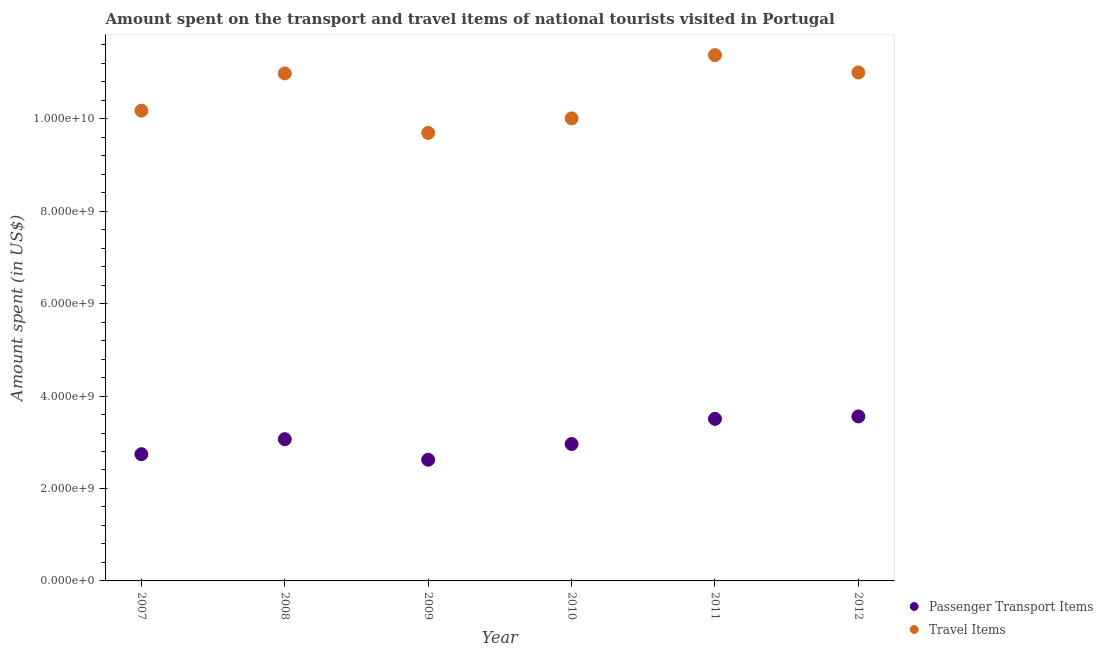How many different coloured dotlines are there?
Your response must be concise. 2. Is the number of dotlines equal to the number of legend labels?
Provide a succinct answer. Yes. What is the amount spent on passenger transport items in 2012?
Give a very brief answer. 3.56e+09. Across all years, what is the maximum amount spent in travel items?
Your answer should be compact. 1.14e+1. Across all years, what is the minimum amount spent on passenger transport items?
Provide a short and direct response. 2.62e+09. In which year was the amount spent on passenger transport items maximum?
Provide a short and direct response. 2012. In which year was the amount spent in travel items minimum?
Provide a short and direct response. 2009. What is the total amount spent on passenger transport items in the graph?
Your answer should be compact. 1.85e+1. What is the difference between the amount spent on passenger transport items in 2007 and that in 2012?
Keep it short and to the point. -8.17e+08. What is the difference between the amount spent in travel items in 2010 and the amount spent on passenger transport items in 2008?
Make the answer very short. 6.94e+09. What is the average amount spent in travel items per year?
Make the answer very short. 1.05e+1. In the year 2008, what is the difference between the amount spent in travel items and amount spent on passenger transport items?
Keep it short and to the point. 7.91e+09. In how many years, is the amount spent in travel items greater than 3600000000 US$?
Your answer should be very brief. 6. What is the ratio of the amount spent in travel items in 2008 to that in 2009?
Make the answer very short. 1.13. Is the amount spent in travel items in 2010 less than that in 2012?
Provide a succinct answer. Yes. Is the difference between the amount spent in travel items in 2007 and 2011 greater than the difference between the amount spent on passenger transport items in 2007 and 2011?
Your answer should be very brief. No. What is the difference between the highest and the second highest amount spent on passenger transport items?
Ensure brevity in your answer.  5.30e+07. What is the difference between the highest and the lowest amount spent in travel items?
Give a very brief answer. 1.68e+09. In how many years, is the amount spent on passenger transport items greater than the average amount spent on passenger transport items taken over all years?
Offer a very short reply. 2. Does the amount spent in travel items monotonically increase over the years?
Provide a short and direct response. No. Is the amount spent on passenger transport items strictly less than the amount spent in travel items over the years?
Offer a very short reply. Yes. How many dotlines are there?
Ensure brevity in your answer.  2. How many years are there in the graph?
Keep it short and to the point. 6. What is the difference between two consecutive major ticks on the Y-axis?
Make the answer very short. 2.00e+09. Are the values on the major ticks of Y-axis written in scientific E-notation?
Offer a very short reply. Yes. Does the graph contain any zero values?
Offer a terse response. No. Does the graph contain grids?
Give a very brief answer. No. Where does the legend appear in the graph?
Provide a succinct answer. Bottom right. How many legend labels are there?
Provide a short and direct response. 2. How are the legend labels stacked?
Offer a terse response. Vertical. What is the title of the graph?
Keep it short and to the point. Amount spent on the transport and travel items of national tourists visited in Portugal. Does "Agricultural land" appear as one of the legend labels in the graph?
Your answer should be compact. No. What is the label or title of the X-axis?
Keep it short and to the point. Year. What is the label or title of the Y-axis?
Offer a very short reply. Amount spent (in US$). What is the Amount spent (in US$) in Passenger Transport Items in 2007?
Your answer should be very brief. 2.74e+09. What is the Amount spent (in US$) in Travel Items in 2007?
Provide a succinct answer. 1.02e+1. What is the Amount spent (in US$) of Passenger Transport Items in 2008?
Make the answer very short. 3.07e+09. What is the Amount spent (in US$) of Travel Items in 2008?
Your answer should be very brief. 1.10e+1. What is the Amount spent (in US$) in Passenger Transport Items in 2009?
Offer a terse response. 2.62e+09. What is the Amount spent (in US$) in Travel Items in 2009?
Your response must be concise. 9.69e+09. What is the Amount spent (in US$) in Passenger Transport Items in 2010?
Ensure brevity in your answer.  2.96e+09. What is the Amount spent (in US$) in Travel Items in 2010?
Make the answer very short. 1.00e+1. What is the Amount spent (in US$) of Passenger Transport Items in 2011?
Make the answer very short. 3.51e+09. What is the Amount spent (in US$) in Travel Items in 2011?
Your answer should be compact. 1.14e+1. What is the Amount spent (in US$) in Passenger Transport Items in 2012?
Make the answer very short. 3.56e+09. What is the Amount spent (in US$) of Travel Items in 2012?
Provide a short and direct response. 1.10e+1. Across all years, what is the maximum Amount spent (in US$) of Passenger Transport Items?
Provide a short and direct response. 3.56e+09. Across all years, what is the maximum Amount spent (in US$) of Travel Items?
Provide a short and direct response. 1.14e+1. Across all years, what is the minimum Amount spent (in US$) in Passenger Transport Items?
Provide a succinct answer. 2.62e+09. Across all years, what is the minimum Amount spent (in US$) of Travel Items?
Keep it short and to the point. 9.69e+09. What is the total Amount spent (in US$) of Passenger Transport Items in the graph?
Offer a very short reply. 1.85e+1. What is the total Amount spent (in US$) of Travel Items in the graph?
Offer a very short reply. 6.32e+1. What is the difference between the Amount spent (in US$) of Passenger Transport Items in 2007 and that in 2008?
Provide a succinct answer. -3.25e+08. What is the difference between the Amount spent (in US$) in Travel Items in 2007 and that in 2008?
Offer a very short reply. -8.05e+08. What is the difference between the Amount spent (in US$) of Passenger Transport Items in 2007 and that in 2009?
Your answer should be compact. 1.20e+08. What is the difference between the Amount spent (in US$) in Travel Items in 2007 and that in 2009?
Ensure brevity in your answer.  4.82e+08. What is the difference between the Amount spent (in US$) of Passenger Transport Items in 2007 and that in 2010?
Your answer should be very brief. -2.20e+08. What is the difference between the Amount spent (in US$) of Travel Items in 2007 and that in 2010?
Provide a short and direct response. 1.68e+08. What is the difference between the Amount spent (in US$) in Passenger Transport Items in 2007 and that in 2011?
Provide a short and direct response. -7.64e+08. What is the difference between the Amount spent (in US$) in Travel Items in 2007 and that in 2011?
Your answer should be very brief. -1.20e+09. What is the difference between the Amount spent (in US$) of Passenger Transport Items in 2007 and that in 2012?
Offer a very short reply. -8.17e+08. What is the difference between the Amount spent (in US$) in Travel Items in 2007 and that in 2012?
Your response must be concise. -8.25e+08. What is the difference between the Amount spent (in US$) in Passenger Transport Items in 2008 and that in 2009?
Your response must be concise. 4.45e+08. What is the difference between the Amount spent (in US$) in Travel Items in 2008 and that in 2009?
Your answer should be compact. 1.29e+09. What is the difference between the Amount spent (in US$) in Passenger Transport Items in 2008 and that in 2010?
Provide a succinct answer. 1.05e+08. What is the difference between the Amount spent (in US$) in Travel Items in 2008 and that in 2010?
Offer a very short reply. 9.73e+08. What is the difference between the Amount spent (in US$) of Passenger Transport Items in 2008 and that in 2011?
Keep it short and to the point. -4.39e+08. What is the difference between the Amount spent (in US$) of Travel Items in 2008 and that in 2011?
Offer a terse response. -3.96e+08. What is the difference between the Amount spent (in US$) in Passenger Transport Items in 2008 and that in 2012?
Offer a very short reply. -4.92e+08. What is the difference between the Amount spent (in US$) of Travel Items in 2008 and that in 2012?
Ensure brevity in your answer.  -2.00e+07. What is the difference between the Amount spent (in US$) of Passenger Transport Items in 2009 and that in 2010?
Your response must be concise. -3.40e+08. What is the difference between the Amount spent (in US$) of Travel Items in 2009 and that in 2010?
Provide a short and direct response. -3.14e+08. What is the difference between the Amount spent (in US$) of Passenger Transport Items in 2009 and that in 2011?
Offer a terse response. -8.84e+08. What is the difference between the Amount spent (in US$) of Travel Items in 2009 and that in 2011?
Offer a very short reply. -1.68e+09. What is the difference between the Amount spent (in US$) of Passenger Transport Items in 2009 and that in 2012?
Your response must be concise. -9.37e+08. What is the difference between the Amount spent (in US$) of Travel Items in 2009 and that in 2012?
Make the answer very short. -1.31e+09. What is the difference between the Amount spent (in US$) in Passenger Transport Items in 2010 and that in 2011?
Your response must be concise. -5.44e+08. What is the difference between the Amount spent (in US$) in Travel Items in 2010 and that in 2011?
Ensure brevity in your answer.  -1.37e+09. What is the difference between the Amount spent (in US$) in Passenger Transport Items in 2010 and that in 2012?
Your response must be concise. -5.97e+08. What is the difference between the Amount spent (in US$) in Travel Items in 2010 and that in 2012?
Give a very brief answer. -9.93e+08. What is the difference between the Amount spent (in US$) of Passenger Transport Items in 2011 and that in 2012?
Provide a short and direct response. -5.30e+07. What is the difference between the Amount spent (in US$) in Travel Items in 2011 and that in 2012?
Give a very brief answer. 3.76e+08. What is the difference between the Amount spent (in US$) of Passenger Transport Items in 2007 and the Amount spent (in US$) of Travel Items in 2008?
Keep it short and to the point. -8.24e+09. What is the difference between the Amount spent (in US$) in Passenger Transport Items in 2007 and the Amount spent (in US$) in Travel Items in 2009?
Make the answer very short. -6.95e+09. What is the difference between the Amount spent (in US$) of Passenger Transport Items in 2007 and the Amount spent (in US$) of Travel Items in 2010?
Your answer should be compact. -7.26e+09. What is the difference between the Amount spent (in US$) in Passenger Transport Items in 2007 and the Amount spent (in US$) in Travel Items in 2011?
Ensure brevity in your answer.  -8.63e+09. What is the difference between the Amount spent (in US$) in Passenger Transport Items in 2007 and the Amount spent (in US$) in Travel Items in 2012?
Offer a terse response. -8.26e+09. What is the difference between the Amount spent (in US$) in Passenger Transport Items in 2008 and the Amount spent (in US$) in Travel Items in 2009?
Provide a succinct answer. -6.63e+09. What is the difference between the Amount spent (in US$) in Passenger Transport Items in 2008 and the Amount spent (in US$) in Travel Items in 2010?
Make the answer very short. -6.94e+09. What is the difference between the Amount spent (in US$) of Passenger Transport Items in 2008 and the Amount spent (in US$) of Travel Items in 2011?
Provide a short and direct response. -8.31e+09. What is the difference between the Amount spent (in US$) in Passenger Transport Items in 2008 and the Amount spent (in US$) in Travel Items in 2012?
Provide a short and direct response. -7.93e+09. What is the difference between the Amount spent (in US$) of Passenger Transport Items in 2009 and the Amount spent (in US$) of Travel Items in 2010?
Make the answer very short. -7.38e+09. What is the difference between the Amount spent (in US$) in Passenger Transport Items in 2009 and the Amount spent (in US$) in Travel Items in 2011?
Ensure brevity in your answer.  -8.75e+09. What is the difference between the Amount spent (in US$) in Passenger Transport Items in 2009 and the Amount spent (in US$) in Travel Items in 2012?
Give a very brief answer. -8.38e+09. What is the difference between the Amount spent (in US$) in Passenger Transport Items in 2010 and the Amount spent (in US$) in Travel Items in 2011?
Make the answer very short. -8.41e+09. What is the difference between the Amount spent (in US$) of Passenger Transport Items in 2010 and the Amount spent (in US$) of Travel Items in 2012?
Your answer should be compact. -8.04e+09. What is the difference between the Amount spent (in US$) in Passenger Transport Items in 2011 and the Amount spent (in US$) in Travel Items in 2012?
Keep it short and to the point. -7.49e+09. What is the average Amount spent (in US$) of Passenger Transport Items per year?
Provide a short and direct response. 3.08e+09. What is the average Amount spent (in US$) of Travel Items per year?
Your answer should be compact. 1.05e+1. In the year 2007, what is the difference between the Amount spent (in US$) of Passenger Transport Items and Amount spent (in US$) of Travel Items?
Provide a short and direct response. -7.43e+09. In the year 2008, what is the difference between the Amount spent (in US$) of Passenger Transport Items and Amount spent (in US$) of Travel Items?
Make the answer very short. -7.91e+09. In the year 2009, what is the difference between the Amount spent (in US$) in Passenger Transport Items and Amount spent (in US$) in Travel Items?
Your answer should be compact. -7.07e+09. In the year 2010, what is the difference between the Amount spent (in US$) of Passenger Transport Items and Amount spent (in US$) of Travel Items?
Keep it short and to the point. -7.04e+09. In the year 2011, what is the difference between the Amount spent (in US$) of Passenger Transport Items and Amount spent (in US$) of Travel Items?
Your answer should be very brief. -7.87e+09. In the year 2012, what is the difference between the Amount spent (in US$) of Passenger Transport Items and Amount spent (in US$) of Travel Items?
Give a very brief answer. -7.44e+09. What is the ratio of the Amount spent (in US$) of Passenger Transport Items in 2007 to that in 2008?
Your answer should be very brief. 0.89. What is the ratio of the Amount spent (in US$) of Travel Items in 2007 to that in 2008?
Ensure brevity in your answer.  0.93. What is the ratio of the Amount spent (in US$) in Passenger Transport Items in 2007 to that in 2009?
Offer a terse response. 1.05. What is the ratio of the Amount spent (in US$) of Travel Items in 2007 to that in 2009?
Keep it short and to the point. 1.05. What is the ratio of the Amount spent (in US$) of Passenger Transport Items in 2007 to that in 2010?
Ensure brevity in your answer.  0.93. What is the ratio of the Amount spent (in US$) of Travel Items in 2007 to that in 2010?
Offer a very short reply. 1.02. What is the ratio of the Amount spent (in US$) in Passenger Transport Items in 2007 to that in 2011?
Make the answer very short. 0.78. What is the ratio of the Amount spent (in US$) in Travel Items in 2007 to that in 2011?
Offer a very short reply. 0.89. What is the ratio of the Amount spent (in US$) of Passenger Transport Items in 2007 to that in 2012?
Provide a short and direct response. 0.77. What is the ratio of the Amount spent (in US$) of Travel Items in 2007 to that in 2012?
Make the answer very short. 0.93. What is the ratio of the Amount spent (in US$) of Passenger Transport Items in 2008 to that in 2009?
Make the answer very short. 1.17. What is the ratio of the Amount spent (in US$) of Travel Items in 2008 to that in 2009?
Give a very brief answer. 1.13. What is the ratio of the Amount spent (in US$) in Passenger Transport Items in 2008 to that in 2010?
Make the answer very short. 1.04. What is the ratio of the Amount spent (in US$) of Travel Items in 2008 to that in 2010?
Ensure brevity in your answer.  1.1. What is the ratio of the Amount spent (in US$) in Passenger Transport Items in 2008 to that in 2011?
Keep it short and to the point. 0.87. What is the ratio of the Amount spent (in US$) in Travel Items in 2008 to that in 2011?
Make the answer very short. 0.97. What is the ratio of the Amount spent (in US$) of Passenger Transport Items in 2008 to that in 2012?
Your answer should be compact. 0.86. What is the ratio of the Amount spent (in US$) in Passenger Transport Items in 2009 to that in 2010?
Provide a succinct answer. 0.89. What is the ratio of the Amount spent (in US$) of Travel Items in 2009 to that in 2010?
Your answer should be very brief. 0.97. What is the ratio of the Amount spent (in US$) of Passenger Transport Items in 2009 to that in 2011?
Give a very brief answer. 0.75. What is the ratio of the Amount spent (in US$) of Travel Items in 2009 to that in 2011?
Offer a terse response. 0.85. What is the ratio of the Amount spent (in US$) of Passenger Transport Items in 2009 to that in 2012?
Offer a terse response. 0.74. What is the ratio of the Amount spent (in US$) of Travel Items in 2009 to that in 2012?
Your answer should be very brief. 0.88. What is the ratio of the Amount spent (in US$) of Passenger Transport Items in 2010 to that in 2011?
Provide a short and direct response. 0.84. What is the ratio of the Amount spent (in US$) of Travel Items in 2010 to that in 2011?
Make the answer very short. 0.88. What is the ratio of the Amount spent (in US$) in Passenger Transport Items in 2010 to that in 2012?
Provide a succinct answer. 0.83. What is the ratio of the Amount spent (in US$) of Travel Items in 2010 to that in 2012?
Provide a succinct answer. 0.91. What is the ratio of the Amount spent (in US$) in Passenger Transport Items in 2011 to that in 2012?
Offer a terse response. 0.99. What is the ratio of the Amount spent (in US$) of Travel Items in 2011 to that in 2012?
Provide a succinct answer. 1.03. What is the difference between the highest and the second highest Amount spent (in US$) in Passenger Transport Items?
Make the answer very short. 5.30e+07. What is the difference between the highest and the second highest Amount spent (in US$) of Travel Items?
Your response must be concise. 3.76e+08. What is the difference between the highest and the lowest Amount spent (in US$) in Passenger Transport Items?
Provide a short and direct response. 9.37e+08. What is the difference between the highest and the lowest Amount spent (in US$) of Travel Items?
Provide a short and direct response. 1.68e+09. 